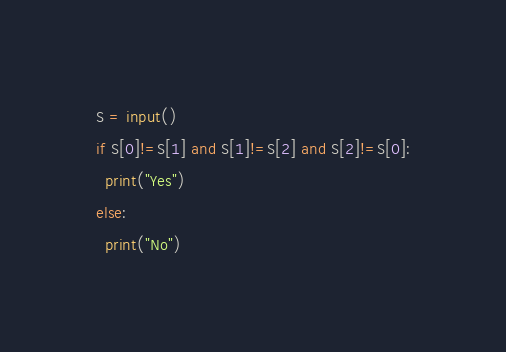Convert code to text. <code><loc_0><loc_0><loc_500><loc_500><_Python_>S = input()
if S[0]!=S[1] and S[1]!=S[2] and S[2]!=S[0]:
  print("Yes")
else:
  print("No")</code> 